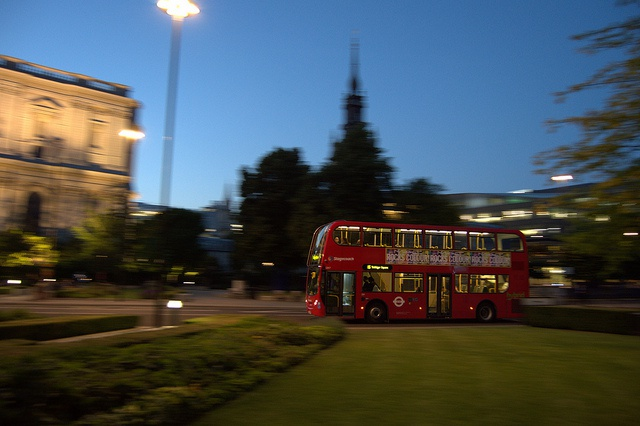Describe the objects in this image and their specific colors. I can see bus in gray, black, maroon, and olive tones, people in gray, black, maroon, and olive tones, people in black, olive, and gray tones, people in black and gray tones, and people in gray, black, and olive tones in this image. 